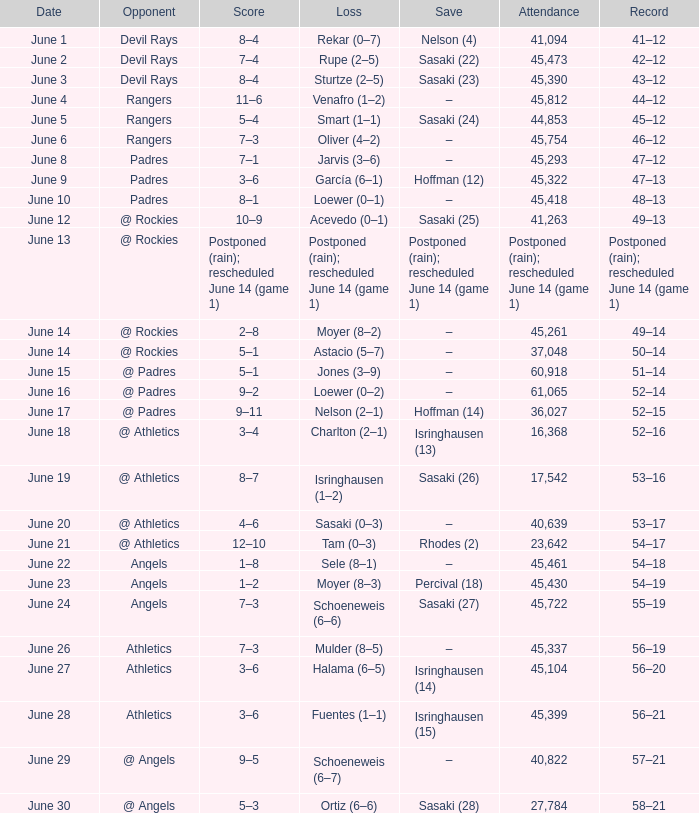What was the attendance of the Mariners game when they had a record of 56–20? 45104.0. 